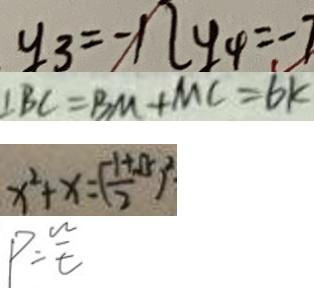Convert formula to latex. <formula><loc_0><loc_0><loc_500><loc_500>y _ { 3 } = - 1 2 y _ { 4 } = - 7 
 \angle B C = B M + M C = 6 k 
 x ^ { 2 } + x = ( \frac { - 1 + \sqrt { 5 } } { 2 } ) ^ { 2 } 
 P = \frac { w } { t }</formula> 